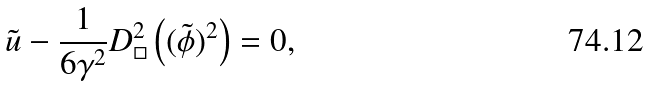Convert formula to latex. <formula><loc_0><loc_0><loc_500><loc_500>\tilde { u } - \frac { 1 } { 6 \gamma ^ { 2 } } D ^ { 2 } _ { \Box } \left ( ( \tilde { \phi } ) ^ { 2 } \right ) = 0 ,</formula> 